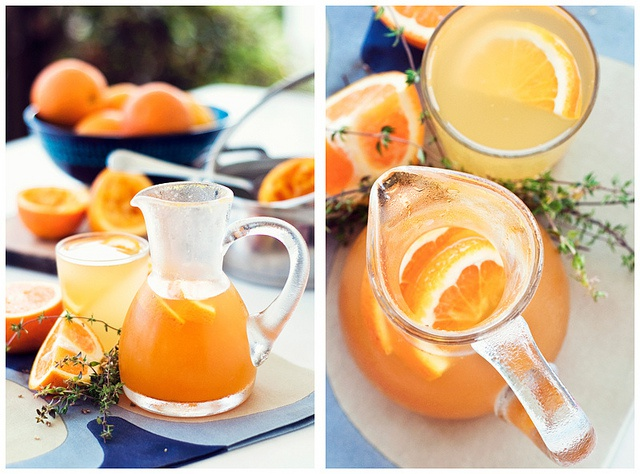Describe the objects in this image and their specific colors. I can see dining table in white, ivory, tan, orange, and gold tones, dining table in white, ivory, orange, tan, and red tones, cup in white, gold, khaki, tan, and beige tones, bowl in white, black, red, and orange tones, and orange in white, tan, orange, red, and ivory tones in this image. 